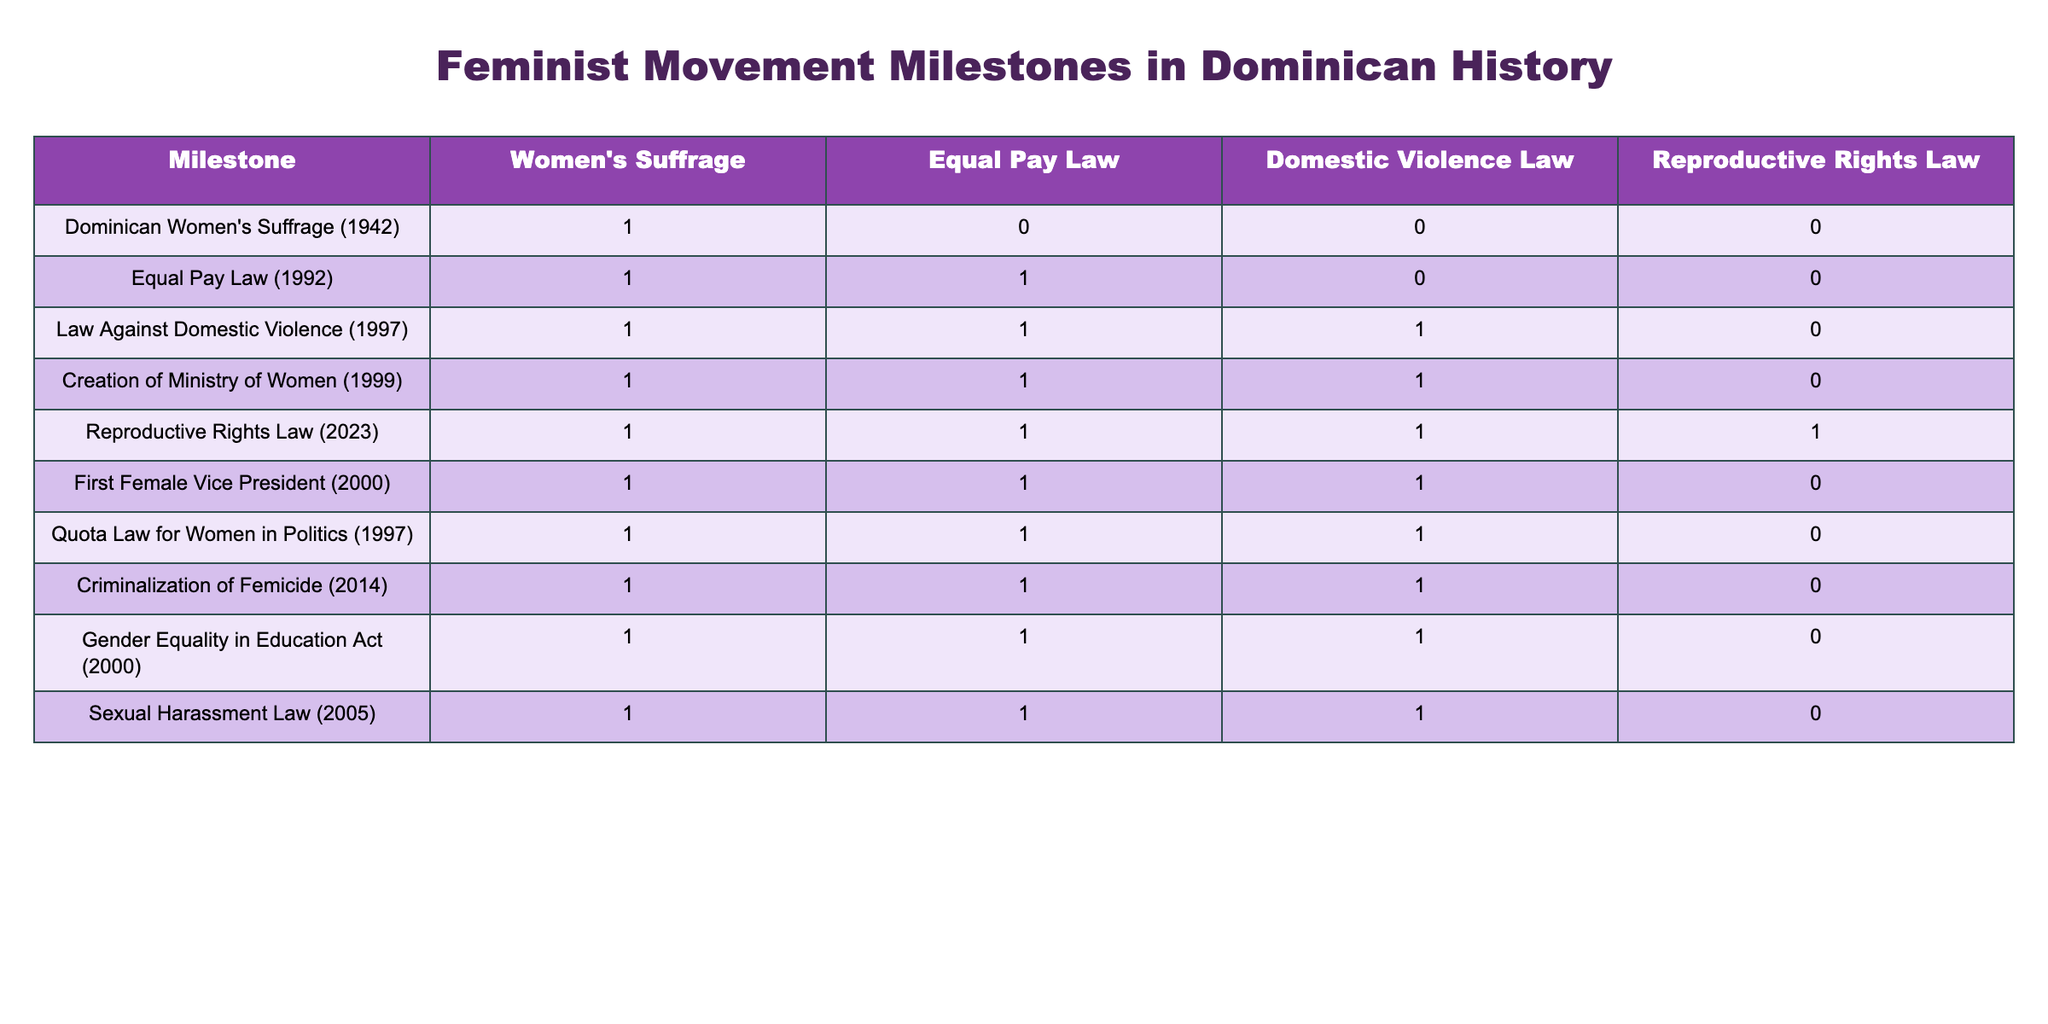What year was women's suffrage granted in the Dominican Republic? According to the table, women's suffrage was granted in 1942.
Answer: 1942 Which law was enacted first: the Equal Pay Law or the Law Against Domestic Violence? The table shows that the Equal Pay Law was enacted in 1992, while the Law Against Domestic Violence was enacted in 1997. Therefore, the Equal Pay Law was enacted first.
Answer: Equal Pay Law How many milestones support reproductive rights? Looking at the table, the milestones supporting reproductive rights are the Reproductive Rights Law (2023), which has a value of 1, and the others before it have 0. Thus, there is only one milestone that supports reproductive rights.
Answer: 1 Did the creation of the Ministry of Women happen before or after the Criminalization of Femicide? The table indicates that the Ministry of Women was created in 1999, while the Criminalization of Femicide occurred in 2014. Therefore, the Ministry of Women was created before the Criminalization of Femicide.
Answer: Before What is the total number of laws relating to domestic violence that are milestones in the table? From the table, there is the Law Against Domestic Violence (1997) that supports domestic violence law (value of 1). Therefore, the total number of milestones concerning domestic violence is one.
Answer: 1 Can you find any milestones that received a value of 1 for both Equal Pay Law and Domestic Violence Law? The table shows that both the Equal Pay Law and the Law Against Domestic Violence received a value of 1 for the milestones in 1992 and 1997. All milestones mentioning both these laws are the Equal Pay Law and the Law Against Domestic Violence.
Answer: Yes Which milestone is the last one to address all four key feminist issues? The Reproductive Rights Law (2023) is the last milestone and addresses all four key issues, as represented by a value of 1 across all columns.
Answer: Reproductive Rights Law (2023) How many milestones did not support Equal Pay Law? Looking at the table, the only milestone that does not support Equal Pay Law is the Dominican Women's Suffrage (1942), others support it. Thus, there is one milestone that does not support Equal Pay Law.
Answer: 1 